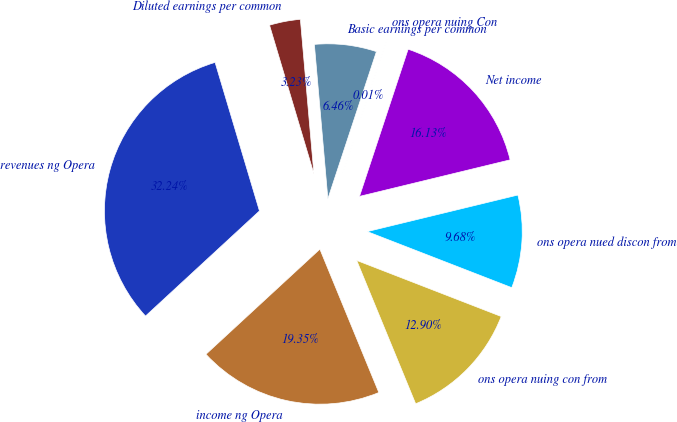Convert chart. <chart><loc_0><loc_0><loc_500><loc_500><pie_chart><fcel>revenues ng Opera<fcel>income ng Opera<fcel>ons opera nuing con from<fcel>ons opera nued discon from<fcel>Net income<fcel>ons opera nuing Con<fcel>Basic earnings per common<fcel>Diluted earnings per common<nl><fcel>32.24%<fcel>19.35%<fcel>12.9%<fcel>9.68%<fcel>16.13%<fcel>0.01%<fcel>6.46%<fcel>3.23%<nl></chart> 